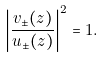<formula> <loc_0><loc_0><loc_500><loc_500>\left | \frac { v _ { \pm } ( z ) } { u _ { \pm } ( z ) } \right | ^ { 2 } = 1 .</formula> 